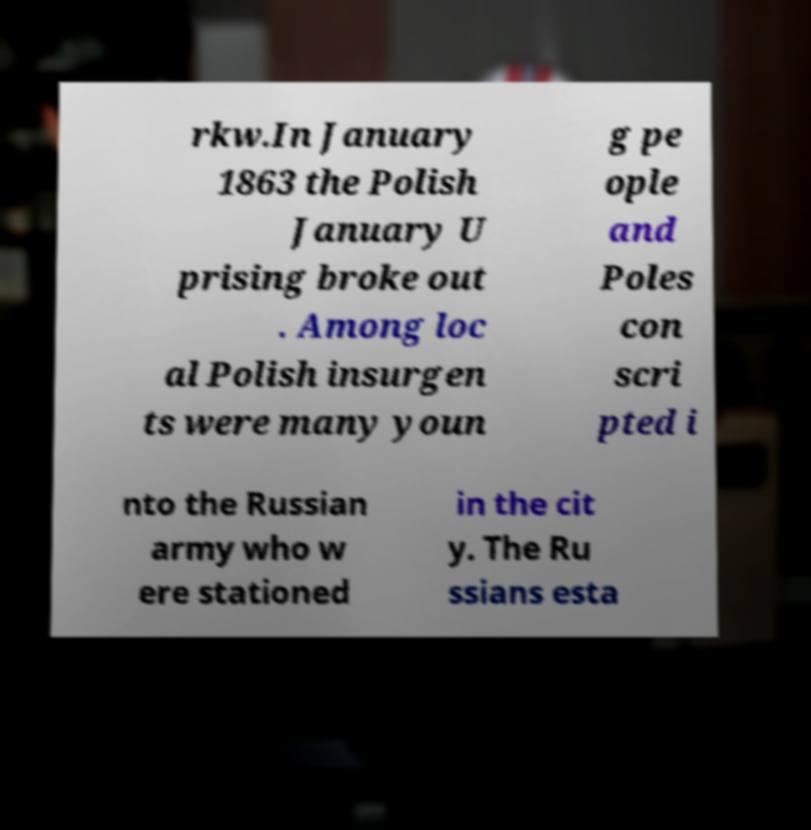Can you read and provide the text displayed in the image?This photo seems to have some interesting text. Can you extract and type it out for me? rkw.In January 1863 the Polish January U prising broke out . Among loc al Polish insurgen ts were many youn g pe ople and Poles con scri pted i nto the Russian army who w ere stationed in the cit y. The Ru ssians esta 